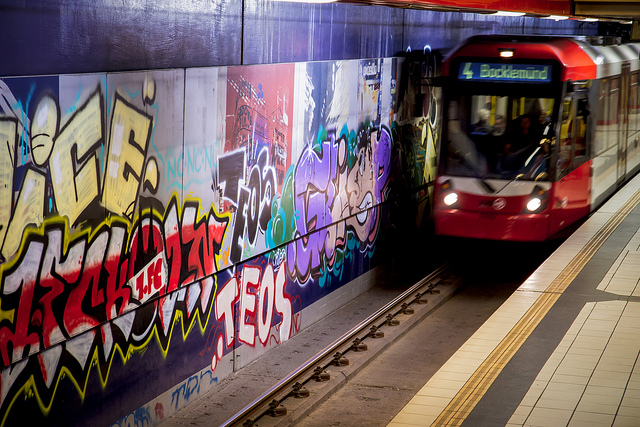Read all the text in this image. 4 TEOS 7.FC TEOS iCE 